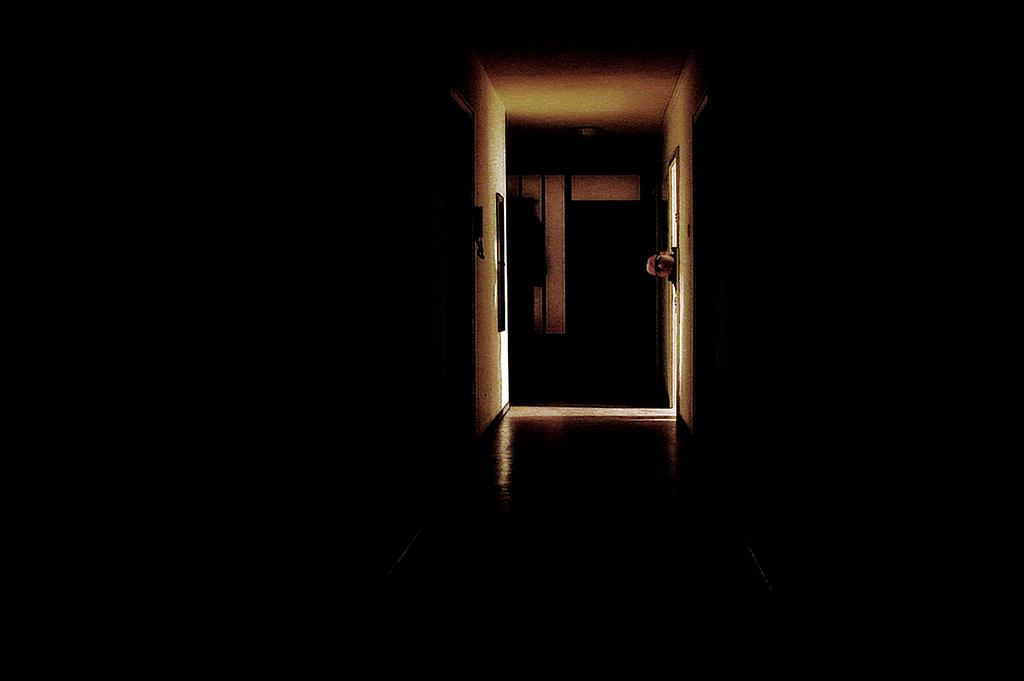What is the primary subject of the image? There is a person in the image. What is the person doing in the image? The person is looking into a corridor from a door. What can be seen through the window in the image? There is a window on the wall in front of the person, but the facts do not specify what can be seen through it. Can you describe the background of the image? There is a door visible in the background of the image. What type of bikes are parked in the corridor in the image? There are no bikes present in the image. What time of day is it in the image, considering it's an afternoon scene? The facts do not specify the time of day, and there is no indication of an afternoon scene in the image. 